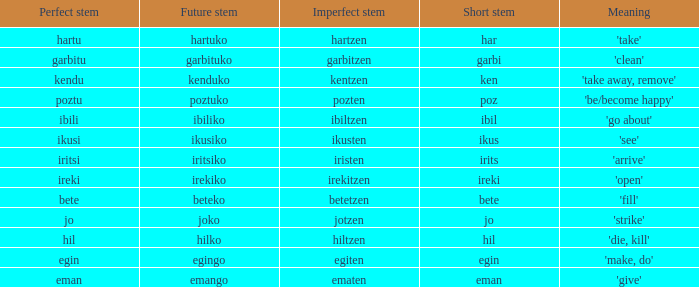Can you provide the impeccable stem for "jo"? 1.0. 